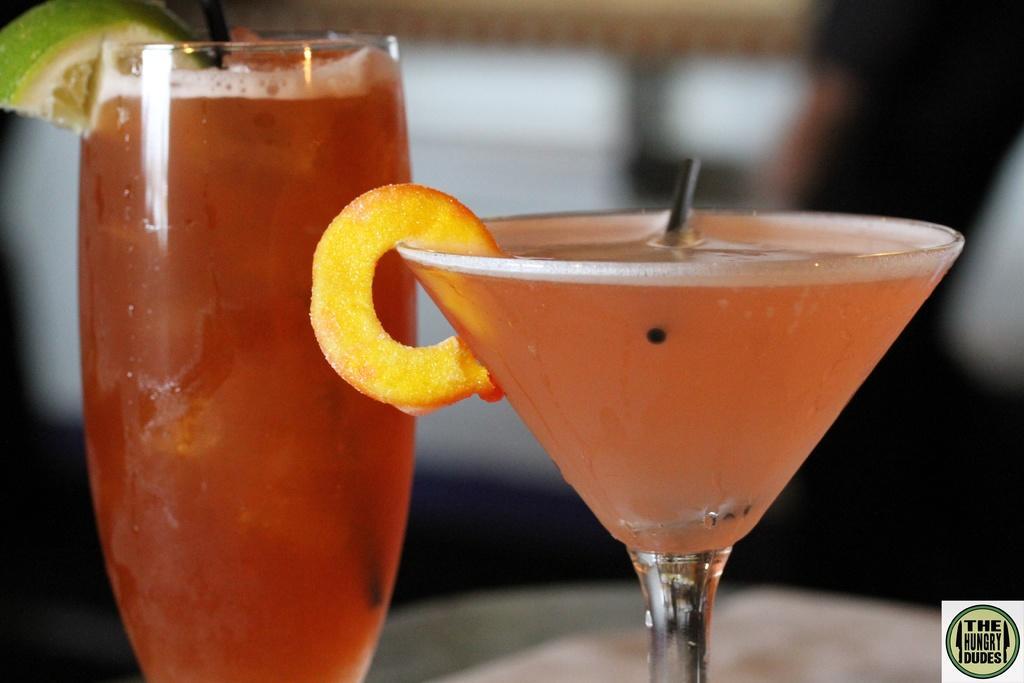Describe this image in one or two sentences. Here in this picture we can see two different glasses which are filled with cool drinks present on the table over there. 